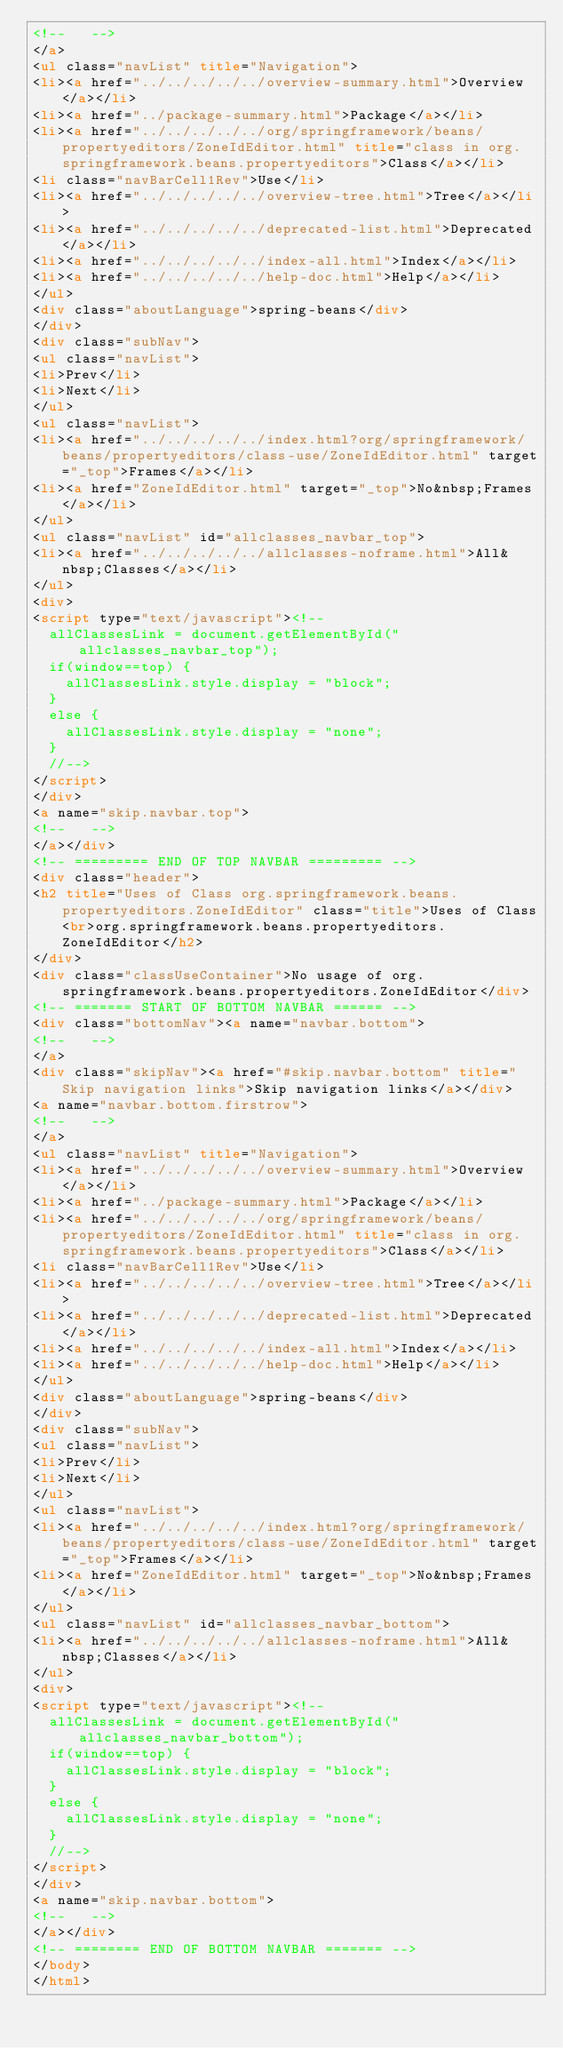Convert code to text. <code><loc_0><loc_0><loc_500><loc_500><_HTML_><!--   -->
</a>
<ul class="navList" title="Navigation">
<li><a href="../../../../../overview-summary.html">Overview</a></li>
<li><a href="../package-summary.html">Package</a></li>
<li><a href="../../../../../org/springframework/beans/propertyeditors/ZoneIdEditor.html" title="class in org.springframework.beans.propertyeditors">Class</a></li>
<li class="navBarCell1Rev">Use</li>
<li><a href="../../../../../overview-tree.html">Tree</a></li>
<li><a href="../../../../../deprecated-list.html">Deprecated</a></li>
<li><a href="../../../../../index-all.html">Index</a></li>
<li><a href="../../../../../help-doc.html">Help</a></li>
</ul>
<div class="aboutLanguage">spring-beans</div>
</div>
<div class="subNav">
<ul class="navList">
<li>Prev</li>
<li>Next</li>
</ul>
<ul class="navList">
<li><a href="../../../../../index.html?org/springframework/beans/propertyeditors/class-use/ZoneIdEditor.html" target="_top">Frames</a></li>
<li><a href="ZoneIdEditor.html" target="_top">No&nbsp;Frames</a></li>
</ul>
<ul class="navList" id="allclasses_navbar_top">
<li><a href="../../../../../allclasses-noframe.html">All&nbsp;Classes</a></li>
</ul>
<div>
<script type="text/javascript"><!--
  allClassesLink = document.getElementById("allclasses_navbar_top");
  if(window==top) {
    allClassesLink.style.display = "block";
  }
  else {
    allClassesLink.style.display = "none";
  }
  //-->
</script>
</div>
<a name="skip.navbar.top">
<!--   -->
</a></div>
<!-- ========= END OF TOP NAVBAR ========= -->
<div class="header">
<h2 title="Uses of Class org.springframework.beans.propertyeditors.ZoneIdEditor" class="title">Uses of Class<br>org.springframework.beans.propertyeditors.ZoneIdEditor</h2>
</div>
<div class="classUseContainer">No usage of org.springframework.beans.propertyeditors.ZoneIdEditor</div>
<!-- ======= START OF BOTTOM NAVBAR ====== -->
<div class="bottomNav"><a name="navbar.bottom">
<!--   -->
</a>
<div class="skipNav"><a href="#skip.navbar.bottom" title="Skip navigation links">Skip navigation links</a></div>
<a name="navbar.bottom.firstrow">
<!--   -->
</a>
<ul class="navList" title="Navigation">
<li><a href="../../../../../overview-summary.html">Overview</a></li>
<li><a href="../package-summary.html">Package</a></li>
<li><a href="../../../../../org/springframework/beans/propertyeditors/ZoneIdEditor.html" title="class in org.springframework.beans.propertyeditors">Class</a></li>
<li class="navBarCell1Rev">Use</li>
<li><a href="../../../../../overview-tree.html">Tree</a></li>
<li><a href="../../../../../deprecated-list.html">Deprecated</a></li>
<li><a href="../../../../../index-all.html">Index</a></li>
<li><a href="../../../../../help-doc.html">Help</a></li>
</ul>
<div class="aboutLanguage">spring-beans</div>
</div>
<div class="subNav">
<ul class="navList">
<li>Prev</li>
<li>Next</li>
</ul>
<ul class="navList">
<li><a href="../../../../../index.html?org/springframework/beans/propertyeditors/class-use/ZoneIdEditor.html" target="_top">Frames</a></li>
<li><a href="ZoneIdEditor.html" target="_top">No&nbsp;Frames</a></li>
</ul>
<ul class="navList" id="allclasses_navbar_bottom">
<li><a href="../../../../../allclasses-noframe.html">All&nbsp;Classes</a></li>
</ul>
<div>
<script type="text/javascript"><!--
  allClassesLink = document.getElementById("allclasses_navbar_bottom");
  if(window==top) {
    allClassesLink.style.display = "block";
  }
  else {
    allClassesLink.style.display = "none";
  }
  //-->
</script>
</div>
<a name="skip.navbar.bottom">
<!--   -->
</a></div>
<!-- ======== END OF BOTTOM NAVBAR ======= -->
</body>
</html>
</code> 